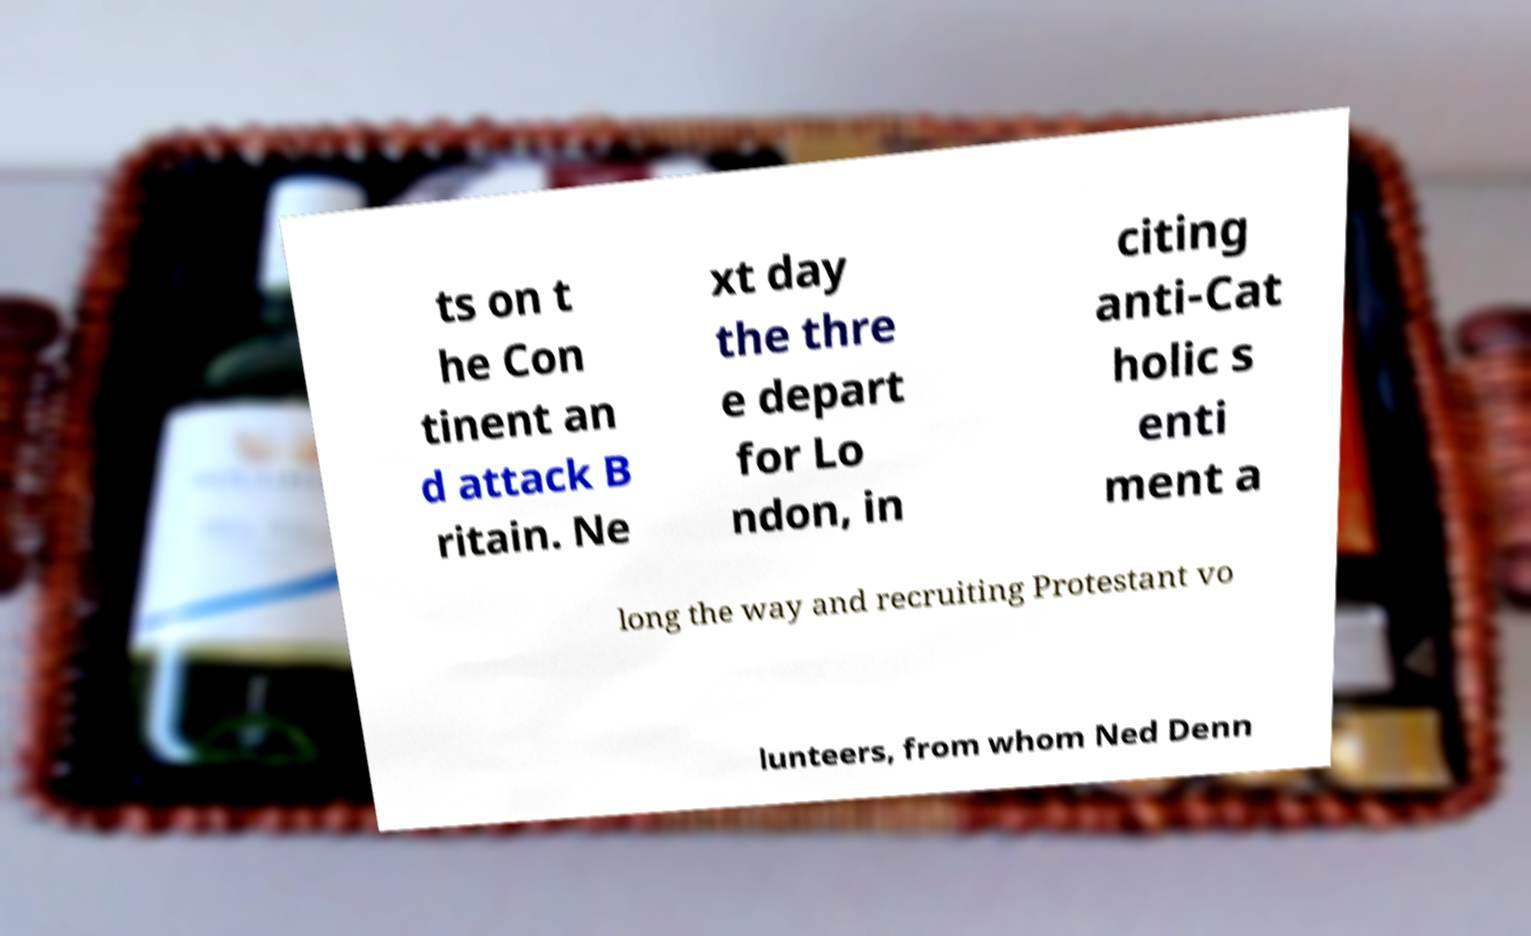What messages or text are displayed in this image? I need them in a readable, typed format. ts on t he Con tinent an d attack B ritain. Ne xt day the thre e depart for Lo ndon, in citing anti-Cat holic s enti ment a long the way and recruiting Protestant vo lunteers, from whom Ned Denn 